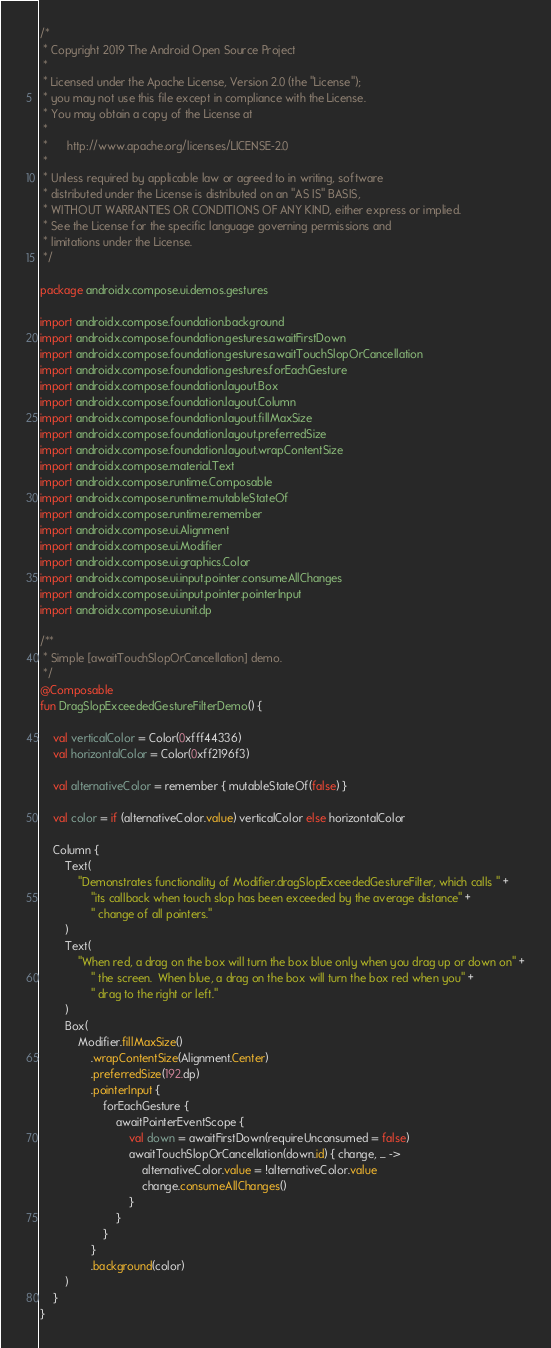<code> <loc_0><loc_0><loc_500><loc_500><_Kotlin_>/*
 * Copyright 2019 The Android Open Source Project
 *
 * Licensed under the Apache License, Version 2.0 (the "License");
 * you may not use this file except in compliance with the License.
 * You may obtain a copy of the License at
 *
 *      http://www.apache.org/licenses/LICENSE-2.0
 *
 * Unless required by applicable law or agreed to in writing, software
 * distributed under the License is distributed on an "AS IS" BASIS,
 * WITHOUT WARRANTIES OR CONDITIONS OF ANY KIND, either express or implied.
 * See the License for the specific language governing permissions and
 * limitations under the License.
 */

package androidx.compose.ui.demos.gestures

import androidx.compose.foundation.background
import androidx.compose.foundation.gestures.awaitFirstDown
import androidx.compose.foundation.gestures.awaitTouchSlopOrCancellation
import androidx.compose.foundation.gestures.forEachGesture
import androidx.compose.foundation.layout.Box
import androidx.compose.foundation.layout.Column
import androidx.compose.foundation.layout.fillMaxSize
import androidx.compose.foundation.layout.preferredSize
import androidx.compose.foundation.layout.wrapContentSize
import androidx.compose.material.Text
import androidx.compose.runtime.Composable
import androidx.compose.runtime.mutableStateOf
import androidx.compose.runtime.remember
import androidx.compose.ui.Alignment
import androidx.compose.ui.Modifier
import androidx.compose.ui.graphics.Color
import androidx.compose.ui.input.pointer.consumeAllChanges
import androidx.compose.ui.input.pointer.pointerInput
import androidx.compose.ui.unit.dp

/**
 * Simple [awaitTouchSlopOrCancellation] demo.
 */
@Composable
fun DragSlopExceededGestureFilterDemo() {

    val verticalColor = Color(0xfff44336)
    val horizontalColor = Color(0xff2196f3)

    val alternativeColor = remember { mutableStateOf(false) }

    val color = if (alternativeColor.value) verticalColor else horizontalColor

    Column {
        Text(
            "Demonstrates functionality of Modifier.dragSlopExceededGestureFilter, which calls " +
                "its callback when touch slop has been exceeded by the average distance" +
                " change of all pointers."
        )
        Text(
            "When red, a drag on the box will turn the box blue only when you drag up or down on" +
                " the screen.  When blue, a drag on the box will turn the box red when you" +
                " drag to the right or left."
        )
        Box(
            Modifier.fillMaxSize()
                .wrapContentSize(Alignment.Center)
                .preferredSize(192.dp)
                .pointerInput {
                    forEachGesture {
                        awaitPointerEventScope {
                            val down = awaitFirstDown(requireUnconsumed = false)
                            awaitTouchSlopOrCancellation(down.id) { change, _ ->
                                alternativeColor.value = !alternativeColor.value
                                change.consumeAllChanges()
                            }
                        }
                    }
                }
                .background(color)
        )
    }
}
</code> 